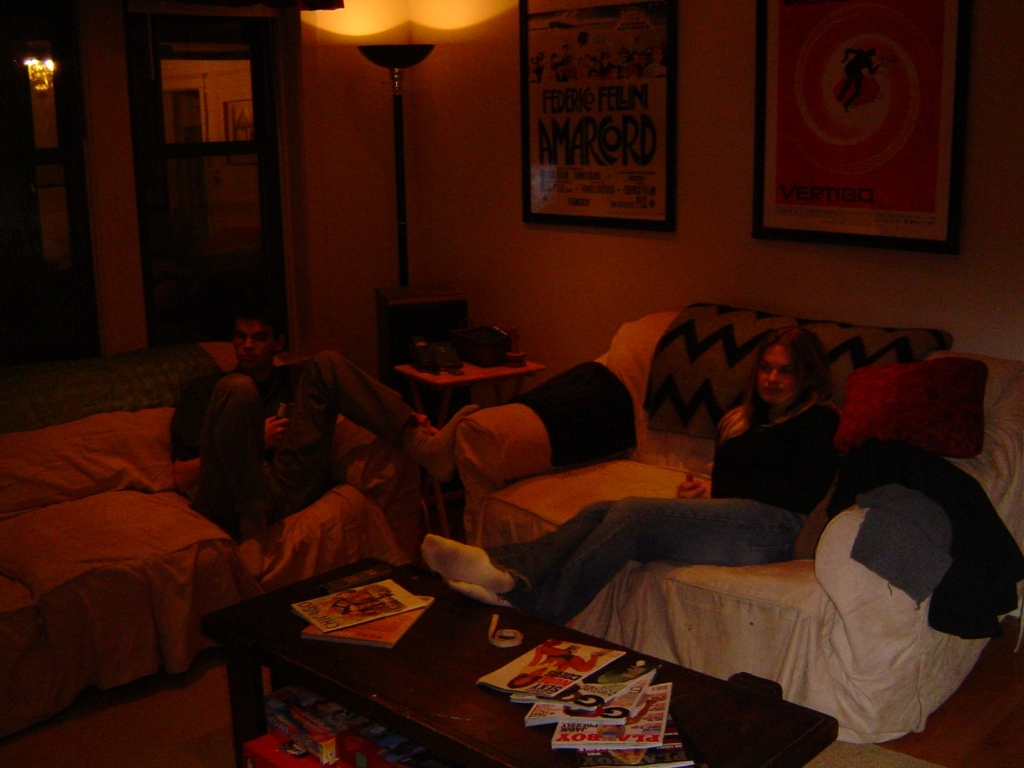Is the quality of the image good? The quality of the image is not ideal. The photograph appears to be taken in low lighting conditions which has resulted in a lack of sharpness and visible graininess. Furthermore, the image is not well-lit, causing some details to be lost in shadowed areas, particularly in the background. It would benefit from better lighting and a higher resolution to improve its clarity. 